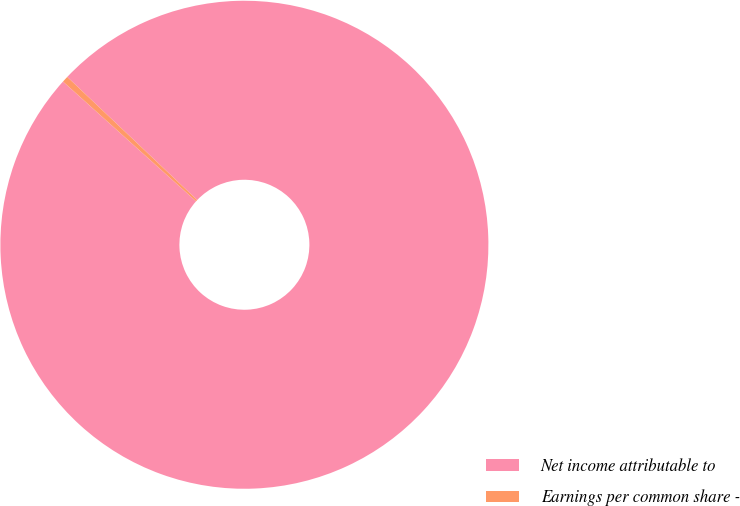<chart> <loc_0><loc_0><loc_500><loc_500><pie_chart><fcel>Net income attributable to<fcel>Earnings per common share -<nl><fcel>99.59%<fcel>0.41%<nl></chart> 